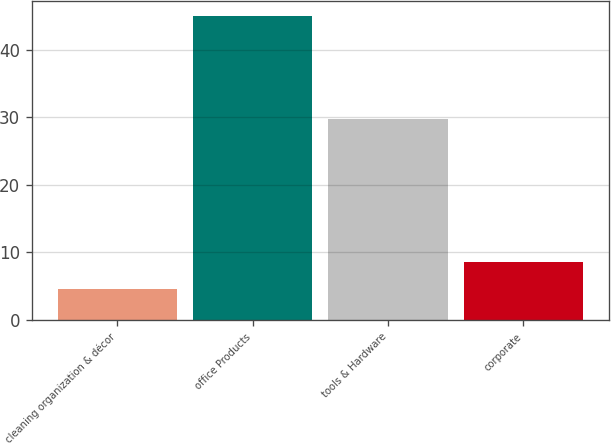<chart> <loc_0><loc_0><loc_500><loc_500><bar_chart><fcel>cleaning organization & décor<fcel>office Products<fcel>tools & Hardware<fcel>corporate<nl><fcel>4.5<fcel>45<fcel>29.7<fcel>8.55<nl></chart> 